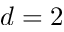<formula> <loc_0><loc_0><loc_500><loc_500>d = 2</formula> 